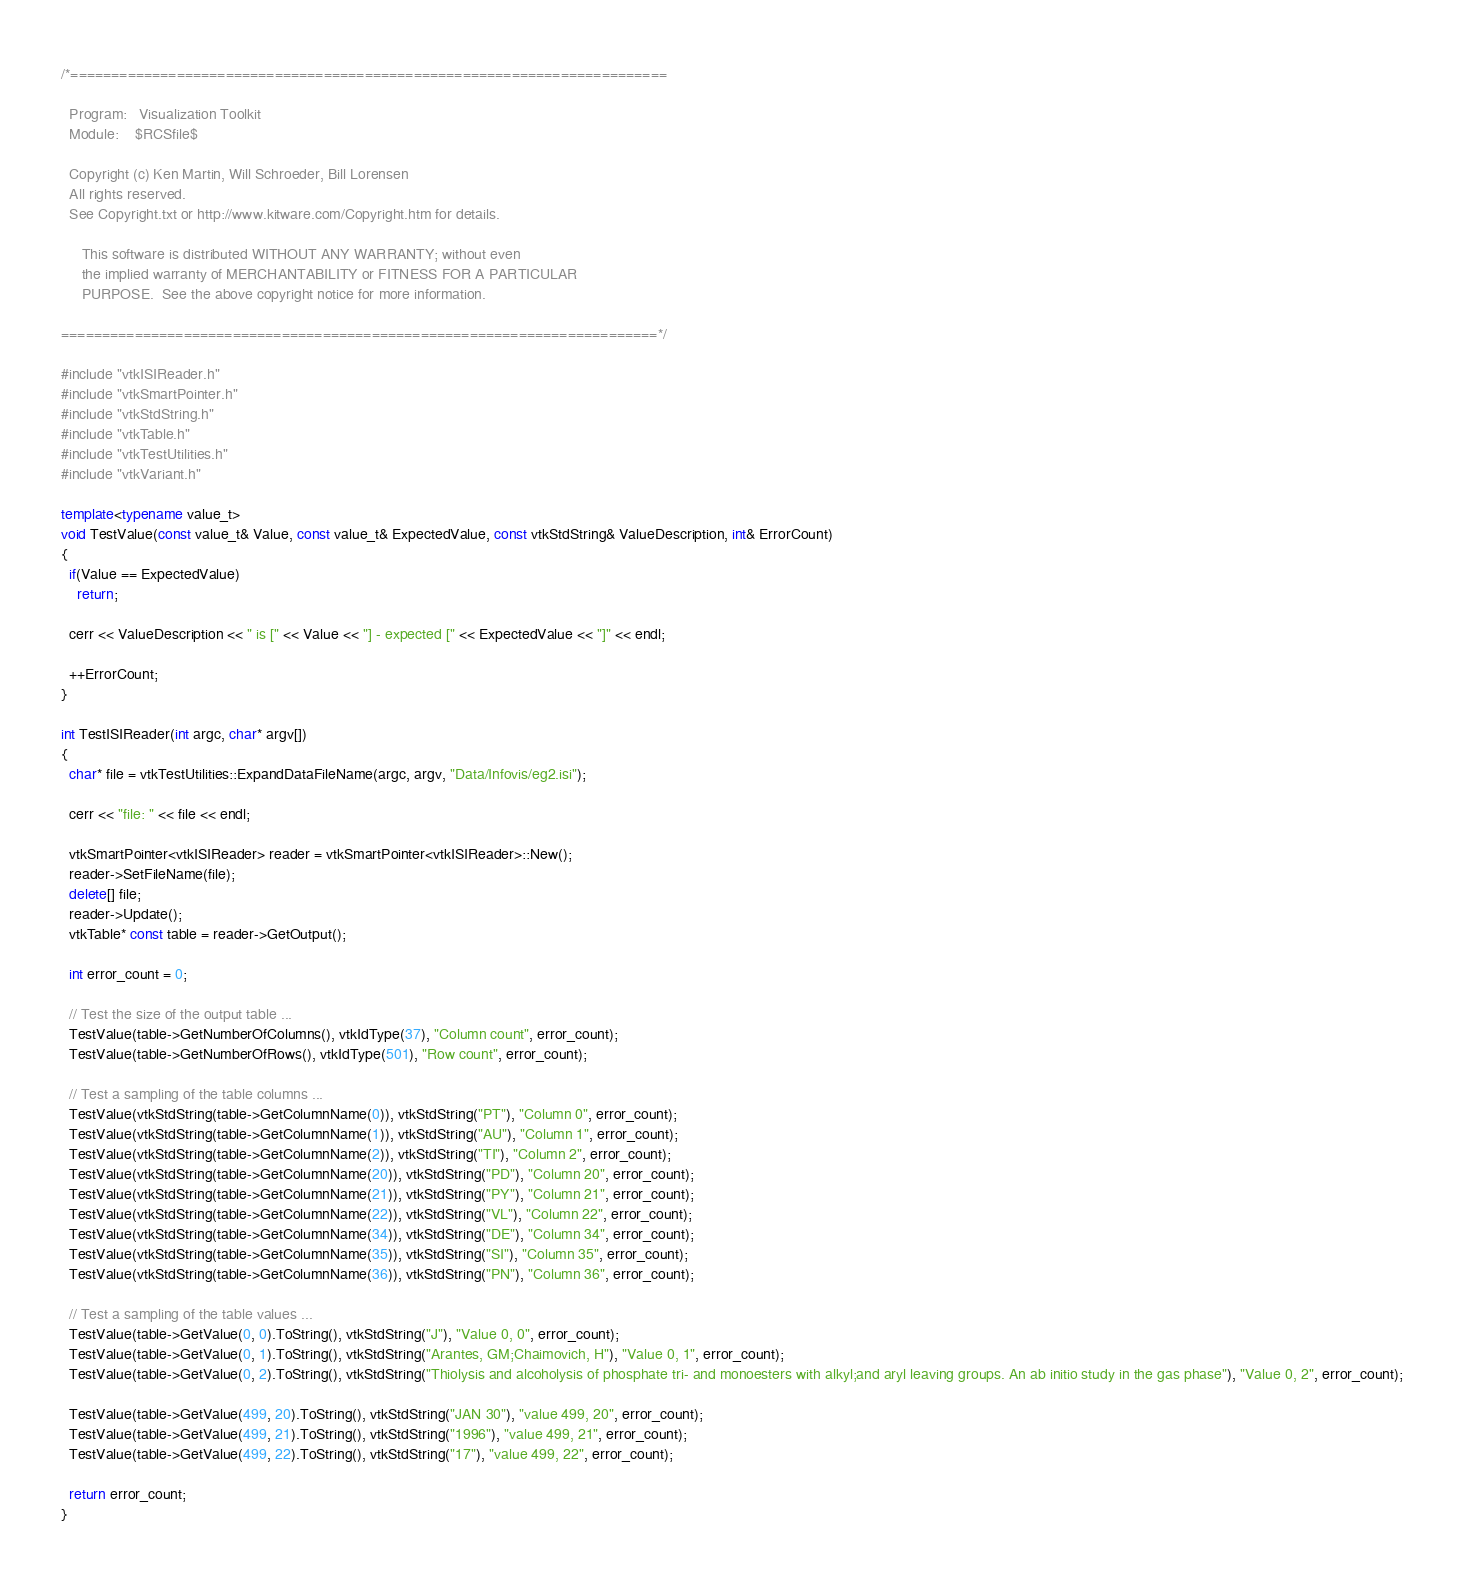<code> <loc_0><loc_0><loc_500><loc_500><_C++_>/*=========================================================================

  Program:   Visualization Toolkit
  Module:    $RCSfile$

  Copyright (c) Ken Martin, Will Schroeder, Bill Lorensen
  All rights reserved.
  See Copyright.txt or http://www.kitware.com/Copyright.htm for details.

     This software is distributed WITHOUT ANY WARRANTY; without even
     the implied warranty of MERCHANTABILITY or FITNESS FOR A PARTICULAR
     PURPOSE.  See the above copyright notice for more information.

=========================================================================*/

#include "vtkISIReader.h"
#include "vtkSmartPointer.h"
#include "vtkStdString.h"
#include "vtkTable.h"
#include "vtkTestUtilities.h"
#include "vtkVariant.h"

template<typename value_t>
void TestValue(const value_t& Value, const value_t& ExpectedValue, const vtkStdString& ValueDescription, int& ErrorCount)
{
  if(Value == ExpectedValue)
    return;

  cerr << ValueDescription << " is [" << Value << "] - expected [" << ExpectedValue << "]" << endl;

  ++ErrorCount;
}

int TestISIReader(int argc, char* argv[])
{
  char* file = vtkTestUtilities::ExpandDataFileName(argc, argv, "Data/Infovis/eg2.isi");

  cerr << "file: " << file << endl;

  vtkSmartPointer<vtkISIReader> reader = vtkSmartPointer<vtkISIReader>::New();
  reader->SetFileName(file);
  delete[] file;
  reader->Update(); 
  vtkTable* const table = reader->GetOutput();

  int error_count = 0; 

  // Test the size of the output table ...
  TestValue(table->GetNumberOfColumns(), vtkIdType(37), "Column count", error_count);
  TestValue(table->GetNumberOfRows(), vtkIdType(501), "Row count", error_count);
  
  // Test a sampling of the table columns ...
  TestValue(vtkStdString(table->GetColumnName(0)), vtkStdString("PT"), "Column 0", error_count);
  TestValue(vtkStdString(table->GetColumnName(1)), vtkStdString("AU"), "Column 1", error_count);
  TestValue(vtkStdString(table->GetColumnName(2)), vtkStdString("TI"), "Column 2", error_count);
  TestValue(vtkStdString(table->GetColumnName(20)), vtkStdString("PD"), "Column 20", error_count);
  TestValue(vtkStdString(table->GetColumnName(21)), vtkStdString("PY"), "Column 21", error_count);
  TestValue(vtkStdString(table->GetColumnName(22)), vtkStdString("VL"), "Column 22", error_count);
  TestValue(vtkStdString(table->GetColumnName(34)), vtkStdString("DE"), "Column 34", error_count);
  TestValue(vtkStdString(table->GetColumnName(35)), vtkStdString("SI"), "Column 35", error_count);
  TestValue(vtkStdString(table->GetColumnName(36)), vtkStdString("PN"), "Column 36", error_count);

  // Test a sampling of the table values ...
  TestValue(table->GetValue(0, 0).ToString(), vtkStdString("J"), "Value 0, 0", error_count);
  TestValue(table->GetValue(0, 1).ToString(), vtkStdString("Arantes, GM;Chaimovich, H"), "Value 0, 1", error_count);
  TestValue(table->GetValue(0, 2).ToString(), vtkStdString("Thiolysis and alcoholysis of phosphate tri- and monoesters with alkyl;and aryl leaving groups. An ab initio study in the gas phase"), "Value 0, 2", error_count);

  TestValue(table->GetValue(499, 20).ToString(), vtkStdString("JAN 30"), "value 499, 20", error_count);
  TestValue(table->GetValue(499, 21).ToString(), vtkStdString("1996"), "value 499, 21", error_count);
  TestValue(table->GetValue(499, 22).ToString(), vtkStdString("17"), "value 499, 22", error_count);
  
  return error_count;
}
</code> 